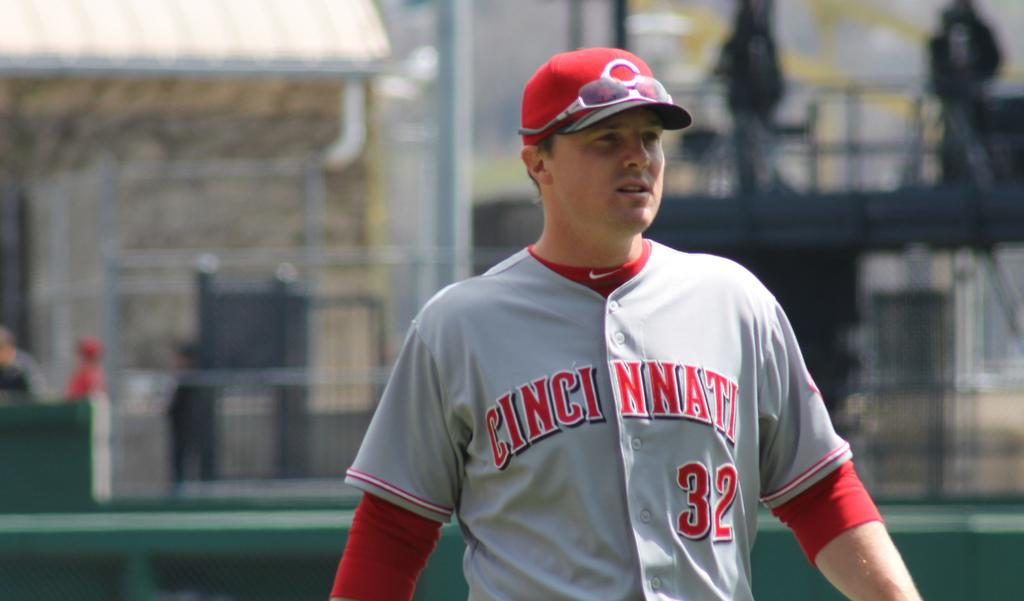<image>
Provide a brief description of the given image. Man wearing a gray and red  jersey that says Cincinnati. 